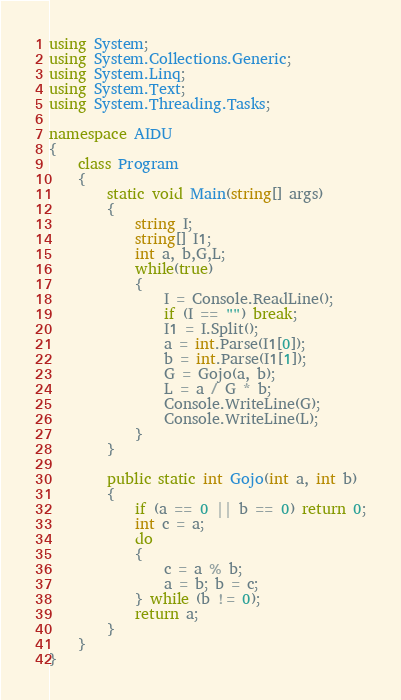Convert code to text. <code><loc_0><loc_0><loc_500><loc_500><_C#_>using System;
using System.Collections.Generic;
using System.Linq;
using System.Text;
using System.Threading.Tasks;

namespace AIDU
{
    class Program
    {
        static void Main(string[] args)
        {
            string I;
            string[] I1;
            int a, b,G,L;
            while(true)
            {
                I = Console.ReadLine();
                if (I == "") break;
                I1 = I.Split();
                a = int.Parse(I1[0]);
                b = int.Parse(I1[1]);
                G = Gojo(a, b);
                L = a / G * b;
                Console.WriteLine(G);
                Console.WriteLine(L);
            }
        }

        public static int Gojo(int a, int b)
        {
            if (a == 0 || b == 0) return 0;
            int c = a;
            do
            {
                c = a % b;
                a = b; b = c;
            } while (b != 0);
            return a;
        }
    }
}</code> 